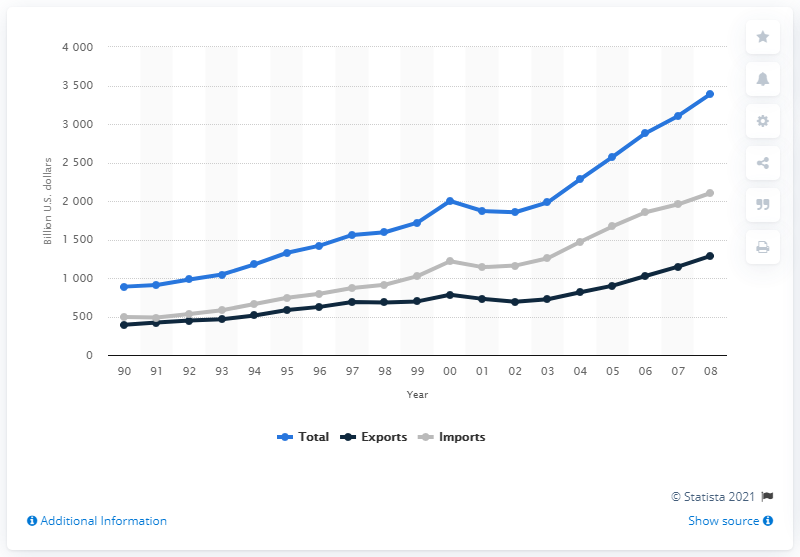Specify some key components in this picture. The total volume of U.S. international merchandise trade in 2000 was X, and in 1982 it was Y. 